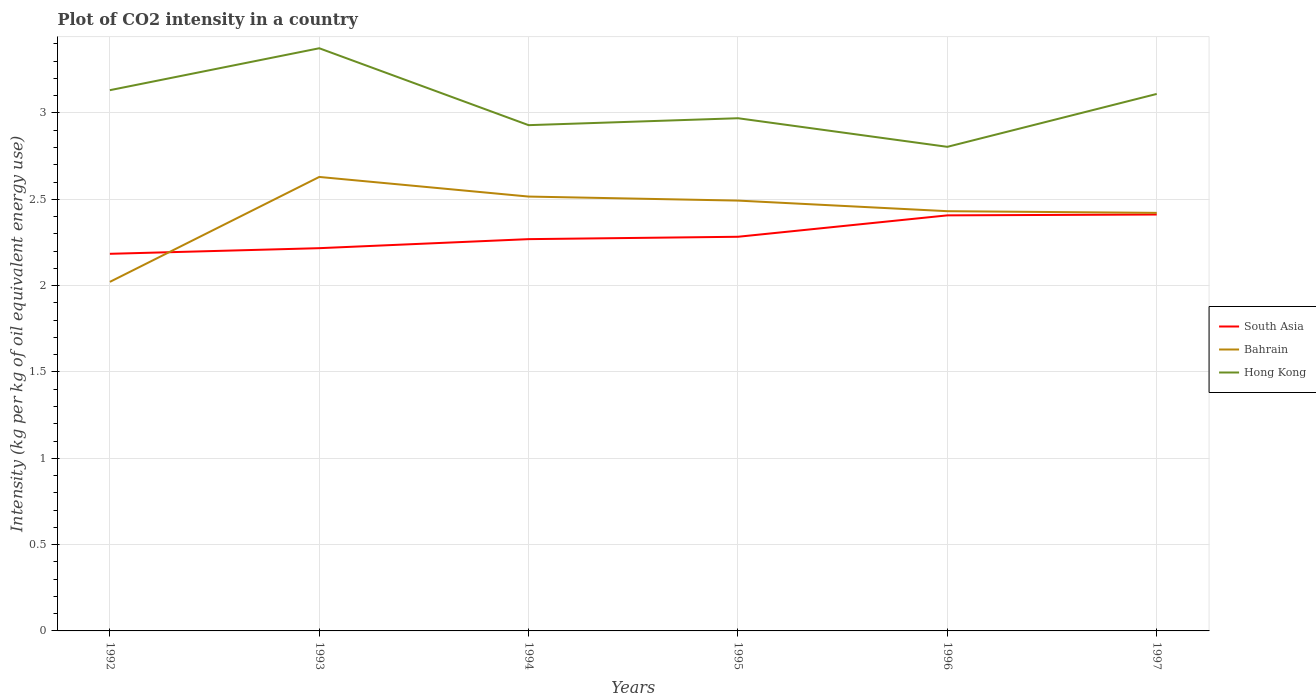Does the line corresponding to South Asia intersect with the line corresponding to Bahrain?
Your response must be concise. Yes. Across all years, what is the maximum CO2 intensity in in Hong Kong?
Your answer should be compact. 2.8. In which year was the CO2 intensity in in South Asia maximum?
Keep it short and to the point. 1992. What is the total CO2 intensity in in South Asia in the graph?
Your answer should be compact. -0.13. What is the difference between the highest and the second highest CO2 intensity in in Bahrain?
Your answer should be very brief. 0.61. What is the difference between two consecutive major ticks on the Y-axis?
Your answer should be very brief. 0.5. Are the values on the major ticks of Y-axis written in scientific E-notation?
Provide a short and direct response. No. Does the graph contain any zero values?
Give a very brief answer. No. Where does the legend appear in the graph?
Your answer should be very brief. Center right. How are the legend labels stacked?
Your response must be concise. Vertical. What is the title of the graph?
Offer a terse response. Plot of CO2 intensity in a country. What is the label or title of the Y-axis?
Provide a short and direct response. Intensity (kg per kg of oil equivalent energy use). What is the Intensity (kg per kg of oil equivalent energy use) of South Asia in 1992?
Offer a very short reply. 2.18. What is the Intensity (kg per kg of oil equivalent energy use) of Bahrain in 1992?
Provide a succinct answer. 2.02. What is the Intensity (kg per kg of oil equivalent energy use) in Hong Kong in 1992?
Keep it short and to the point. 3.13. What is the Intensity (kg per kg of oil equivalent energy use) in South Asia in 1993?
Ensure brevity in your answer.  2.22. What is the Intensity (kg per kg of oil equivalent energy use) in Bahrain in 1993?
Keep it short and to the point. 2.63. What is the Intensity (kg per kg of oil equivalent energy use) in Hong Kong in 1993?
Make the answer very short. 3.38. What is the Intensity (kg per kg of oil equivalent energy use) in South Asia in 1994?
Your answer should be compact. 2.27. What is the Intensity (kg per kg of oil equivalent energy use) in Bahrain in 1994?
Offer a terse response. 2.52. What is the Intensity (kg per kg of oil equivalent energy use) in Hong Kong in 1994?
Make the answer very short. 2.93. What is the Intensity (kg per kg of oil equivalent energy use) of South Asia in 1995?
Offer a very short reply. 2.28. What is the Intensity (kg per kg of oil equivalent energy use) of Bahrain in 1995?
Give a very brief answer. 2.49. What is the Intensity (kg per kg of oil equivalent energy use) of Hong Kong in 1995?
Offer a very short reply. 2.97. What is the Intensity (kg per kg of oil equivalent energy use) of South Asia in 1996?
Your answer should be compact. 2.41. What is the Intensity (kg per kg of oil equivalent energy use) in Bahrain in 1996?
Make the answer very short. 2.43. What is the Intensity (kg per kg of oil equivalent energy use) in Hong Kong in 1996?
Offer a terse response. 2.8. What is the Intensity (kg per kg of oil equivalent energy use) of South Asia in 1997?
Give a very brief answer. 2.41. What is the Intensity (kg per kg of oil equivalent energy use) in Bahrain in 1997?
Give a very brief answer. 2.42. What is the Intensity (kg per kg of oil equivalent energy use) in Hong Kong in 1997?
Provide a succinct answer. 3.11. Across all years, what is the maximum Intensity (kg per kg of oil equivalent energy use) in South Asia?
Provide a succinct answer. 2.41. Across all years, what is the maximum Intensity (kg per kg of oil equivalent energy use) in Bahrain?
Your answer should be compact. 2.63. Across all years, what is the maximum Intensity (kg per kg of oil equivalent energy use) of Hong Kong?
Offer a terse response. 3.38. Across all years, what is the minimum Intensity (kg per kg of oil equivalent energy use) in South Asia?
Offer a very short reply. 2.18. Across all years, what is the minimum Intensity (kg per kg of oil equivalent energy use) in Bahrain?
Ensure brevity in your answer.  2.02. Across all years, what is the minimum Intensity (kg per kg of oil equivalent energy use) in Hong Kong?
Ensure brevity in your answer.  2.8. What is the total Intensity (kg per kg of oil equivalent energy use) of South Asia in the graph?
Your answer should be very brief. 13.77. What is the total Intensity (kg per kg of oil equivalent energy use) in Bahrain in the graph?
Ensure brevity in your answer.  14.51. What is the total Intensity (kg per kg of oil equivalent energy use) in Hong Kong in the graph?
Give a very brief answer. 18.32. What is the difference between the Intensity (kg per kg of oil equivalent energy use) of South Asia in 1992 and that in 1993?
Offer a terse response. -0.03. What is the difference between the Intensity (kg per kg of oil equivalent energy use) of Bahrain in 1992 and that in 1993?
Make the answer very short. -0.61. What is the difference between the Intensity (kg per kg of oil equivalent energy use) in Hong Kong in 1992 and that in 1993?
Keep it short and to the point. -0.24. What is the difference between the Intensity (kg per kg of oil equivalent energy use) in South Asia in 1992 and that in 1994?
Provide a succinct answer. -0.08. What is the difference between the Intensity (kg per kg of oil equivalent energy use) of Bahrain in 1992 and that in 1994?
Ensure brevity in your answer.  -0.49. What is the difference between the Intensity (kg per kg of oil equivalent energy use) in Hong Kong in 1992 and that in 1994?
Your answer should be very brief. 0.2. What is the difference between the Intensity (kg per kg of oil equivalent energy use) in South Asia in 1992 and that in 1995?
Offer a very short reply. -0.1. What is the difference between the Intensity (kg per kg of oil equivalent energy use) of Bahrain in 1992 and that in 1995?
Your answer should be very brief. -0.47. What is the difference between the Intensity (kg per kg of oil equivalent energy use) of Hong Kong in 1992 and that in 1995?
Provide a short and direct response. 0.16. What is the difference between the Intensity (kg per kg of oil equivalent energy use) in South Asia in 1992 and that in 1996?
Ensure brevity in your answer.  -0.22. What is the difference between the Intensity (kg per kg of oil equivalent energy use) in Bahrain in 1992 and that in 1996?
Your answer should be very brief. -0.41. What is the difference between the Intensity (kg per kg of oil equivalent energy use) of Hong Kong in 1992 and that in 1996?
Offer a very short reply. 0.33. What is the difference between the Intensity (kg per kg of oil equivalent energy use) in South Asia in 1992 and that in 1997?
Offer a terse response. -0.23. What is the difference between the Intensity (kg per kg of oil equivalent energy use) of Bahrain in 1992 and that in 1997?
Your answer should be very brief. -0.4. What is the difference between the Intensity (kg per kg of oil equivalent energy use) in Hong Kong in 1992 and that in 1997?
Make the answer very short. 0.02. What is the difference between the Intensity (kg per kg of oil equivalent energy use) of South Asia in 1993 and that in 1994?
Offer a terse response. -0.05. What is the difference between the Intensity (kg per kg of oil equivalent energy use) of Bahrain in 1993 and that in 1994?
Make the answer very short. 0.11. What is the difference between the Intensity (kg per kg of oil equivalent energy use) in Hong Kong in 1993 and that in 1994?
Offer a terse response. 0.45. What is the difference between the Intensity (kg per kg of oil equivalent energy use) of South Asia in 1993 and that in 1995?
Provide a succinct answer. -0.07. What is the difference between the Intensity (kg per kg of oil equivalent energy use) of Bahrain in 1993 and that in 1995?
Your response must be concise. 0.14. What is the difference between the Intensity (kg per kg of oil equivalent energy use) in Hong Kong in 1993 and that in 1995?
Offer a very short reply. 0.41. What is the difference between the Intensity (kg per kg of oil equivalent energy use) in South Asia in 1993 and that in 1996?
Give a very brief answer. -0.19. What is the difference between the Intensity (kg per kg of oil equivalent energy use) in Bahrain in 1993 and that in 1996?
Provide a succinct answer. 0.2. What is the difference between the Intensity (kg per kg of oil equivalent energy use) in Hong Kong in 1993 and that in 1996?
Provide a short and direct response. 0.57. What is the difference between the Intensity (kg per kg of oil equivalent energy use) in South Asia in 1993 and that in 1997?
Your answer should be compact. -0.19. What is the difference between the Intensity (kg per kg of oil equivalent energy use) in Bahrain in 1993 and that in 1997?
Provide a succinct answer. 0.21. What is the difference between the Intensity (kg per kg of oil equivalent energy use) of Hong Kong in 1993 and that in 1997?
Your answer should be very brief. 0.26. What is the difference between the Intensity (kg per kg of oil equivalent energy use) in South Asia in 1994 and that in 1995?
Give a very brief answer. -0.01. What is the difference between the Intensity (kg per kg of oil equivalent energy use) in Bahrain in 1994 and that in 1995?
Give a very brief answer. 0.02. What is the difference between the Intensity (kg per kg of oil equivalent energy use) of Hong Kong in 1994 and that in 1995?
Provide a succinct answer. -0.04. What is the difference between the Intensity (kg per kg of oil equivalent energy use) in South Asia in 1994 and that in 1996?
Your answer should be compact. -0.14. What is the difference between the Intensity (kg per kg of oil equivalent energy use) in Bahrain in 1994 and that in 1996?
Your answer should be compact. 0.08. What is the difference between the Intensity (kg per kg of oil equivalent energy use) of Hong Kong in 1994 and that in 1996?
Your answer should be compact. 0.13. What is the difference between the Intensity (kg per kg of oil equivalent energy use) in South Asia in 1994 and that in 1997?
Offer a terse response. -0.14. What is the difference between the Intensity (kg per kg of oil equivalent energy use) of Bahrain in 1994 and that in 1997?
Your answer should be compact. 0.09. What is the difference between the Intensity (kg per kg of oil equivalent energy use) of Hong Kong in 1994 and that in 1997?
Your answer should be very brief. -0.18. What is the difference between the Intensity (kg per kg of oil equivalent energy use) in South Asia in 1995 and that in 1996?
Offer a terse response. -0.12. What is the difference between the Intensity (kg per kg of oil equivalent energy use) in Bahrain in 1995 and that in 1996?
Give a very brief answer. 0.06. What is the difference between the Intensity (kg per kg of oil equivalent energy use) in Hong Kong in 1995 and that in 1996?
Keep it short and to the point. 0.17. What is the difference between the Intensity (kg per kg of oil equivalent energy use) in South Asia in 1995 and that in 1997?
Ensure brevity in your answer.  -0.13. What is the difference between the Intensity (kg per kg of oil equivalent energy use) in Bahrain in 1995 and that in 1997?
Your response must be concise. 0.07. What is the difference between the Intensity (kg per kg of oil equivalent energy use) in Hong Kong in 1995 and that in 1997?
Your answer should be very brief. -0.14. What is the difference between the Intensity (kg per kg of oil equivalent energy use) of South Asia in 1996 and that in 1997?
Give a very brief answer. -0. What is the difference between the Intensity (kg per kg of oil equivalent energy use) in Bahrain in 1996 and that in 1997?
Make the answer very short. 0.01. What is the difference between the Intensity (kg per kg of oil equivalent energy use) in Hong Kong in 1996 and that in 1997?
Provide a succinct answer. -0.31. What is the difference between the Intensity (kg per kg of oil equivalent energy use) of South Asia in 1992 and the Intensity (kg per kg of oil equivalent energy use) of Bahrain in 1993?
Give a very brief answer. -0.45. What is the difference between the Intensity (kg per kg of oil equivalent energy use) in South Asia in 1992 and the Intensity (kg per kg of oil equivalent energy use) in Hong Kong in 1993?
Offer a very short reply. -1.19. What is the difference between the Intensity (kg per kg of oil equivalent energy use) of Bahrain in 1992 and the Intensity (kg per kg of oil equivalent energy use) of Hong Kong in 1993?
Keep it short and to the point. -1.35. What is the difference between the Intensity (kg per kg of oil equivalent energy use) in South Asia in 1992 and the Intensity (kg per kg of oil equivalent energy use) in Bahrain in 1994?
Provide a succinct answer. -0.33. What is the difference between the Intensity (kg per kg of oil equivalent energy use) of South Asia in 1992 and the Intensity (kg per kg of oil equivalent energy use) of Hong Kong in 1994?
Keep it short and to the point. -0.75. What is the difference between the Intensity (kg per kg of oil equivalent energy use) of Bahrain in 1992 and the Intensity (kg per kg of oil equivalent energy use) of Hong Kong in 1994?
Give a very brief answer. -0.91. What is the difference between the Intensity (kg per kg of oil equivalent energy use) in South Asia in 1992 and the Intensity (kg per kg of oil equivalent energy use) in Bahrain in 1995?
Your response must be concise. -0.31. What is the difference between the Intensity (kg per kg of oil equivalent energy use) in South Asia in 1992 and the Intensity (kg per kg of oil equivalent energy use) in Hong Kong in 1995?
Your answer should be very brief. -0.79. What is the difference between the Intensity (kg per kg of oil equivalent energy use) in Bahrain in 1992 and the Intensity (kg per kg of oil equivalent energy use) in Hong Kong in 1995?
Give a very brief answer. -0.95. What is the difference between the Intensity (kg per kg of oil equivalent energy use) in South Asia in 1992 and the Intensity (kg per kg of oil equivalent energy use) in Bahrain in 1996?
Provide a succinct answer. -0.25. What is the difference between the Intensity (kg per kg of oil equivalent energy use) of South Asia in 1992 and the Intensity (kg per kg of oil equivalent energy use) of Hong Kong in 1996?
Your answer should be very brief. -0.62. What is the difference between the Intensity (kg per kg of oil equivalent energy use) of Bahrain in 1992 and the Intensity (kg per kg of oil equivalent energy use) of Hong Kong in 1996?
Make the answer very short. -0.78. What is the difference between the Intensity (kg per kg of oil equivalent energy use) in South Asia in 1992 and the Intensity (kg per kg of oil equivalent energy use) in Bahrain in 1997?
Make the answer very short. -0.24. What is the difference between the Intensity (kg per kg of oil equivalent energy use) of South Asia in 1992 and the Intensity (kg per kg of oil equivalent energy use) of Hong Kong in 1997?
Your answer should be compact. -0.93. What is the difference between the Intensity (kg per kg of oil equivalent energy use) of Bahrain in 1992 and the Intensity (kg per kg of oil equivalent energy use) of Hong Kong in 1997?
Ensure brevity in your answer.  -1.09. What is the difference between the Intensity (kg per kg of oil equivalent energy use) in South Asia in 1993 and the Intensity (kg per kg of oil equivalent energy use) in Bahrain in 1994?
Provide a succinct answer. -0.3. What is the difference between the Intensity (kg per kg of oil equivalent energy use) in South Asia in 1993 and the Intensity (kg per kg of oil equivalent energy use) in Hong Kong in 1994?
Ensure brevity in your answer.  -0.71. What is the difference between the Intensity (kg per kg of oil equivalent energy use) of Bahrain in 1993 and the Intensity (kg per kg of oil equivalent energy use) of Hong Kong in 1994?
Your answer should be very brief. -0.3. What is the difference between the Intensity (kg per kg of oil equivalent energy use) of South Asia in 1993 and the Intensity (kg per kg of oil equivalent energy use) of Bahrain in 1995?
Provide a short and direct response. -0.28. What is the difference between the Intensity (kg per kg of oil equivalent energy use) in South Asia in 1993 and the Intensity (kg per kg of oil equivalent energy use) in Hong Kong in 1995?
Provide a short and direct response. -0.75. What is the difference between the Intensity (kg per kg of oil equivalent energy use) of Bahrain in 1993 and the Intensity (kg per kg of oil equivalent energy use) of Hong Kong in 1995?
Your answer should be very brief. -0.34. What is the difference between the Intensity (kg per kg of oil equivalent energy use) in South Asia in 1993 and the Intensity (kg per kg of oil equivalent energy use) in Bahrain in 1996?
Offer a very short reply. -0.21. What is the difference between the Intensity (kg per kg of oil equivalent energy use) of South Asia in 1993 and the Intensity (kg per kg of oil equivalent energy use) of Hong Kong in 1996?
Ensure brevity in your answer.  -0.59. What is the difference between the Intensity (kg per kg of oil equivalent energy use) in Bahrain in 1993 and the Intensity (kg per kg of oil equivalent energy use) in Hong Kong in 1996?
Offer a very short reply. -0.17. What is the difference between the Intensity (kg per kg of oil equivalent energy use) in South Asia in 1993 and the Intensity (kg per kg of oil equivalent energy use) in Bahrain in 1997?
Offer a very short reply. -0.2. What is the difference between the Intensity (kg per kg of oil equivalent energy use) in South Asia in 1993 and the Intensity (kg per kg of oil equivalent energy use) in Hong Kong in 1997?
Your response must be concise. -0.89. What is the difference between the Intensity (kg per kg of oil equivalent energy use) of Bahrain in 1993 and the Intensity (kg per kg of oil equivalent energy use) of Hong Kong in 1997?
Ensure brevity in your answer.  -0.48. What is the difference between the Intensity (kg per kg of oil equivalent energy use) in South Asia in 1994 and the Intensity (kg per kg of oil equivalent energy use) in Bahrain in 1995?
Make the answer very short. -0.22. What is the difference between the Intensity (kg per kg of oil equivalent energy use) of South Asia in 1994 and the Intensity (kg per kg of oil equivalent energy use) of Hong Kong in 1995?
Give a very brief answer. -0.7. What is the difference between the Intensity (kg per kg of oil equivalent energy use) in Bahrain in 1994 and the Intensity (kg per kg of oil equivalent energy use) in Hong Kong in 1995?
Provide a short and direct response. -0.45. What is the difference between the Intensity (kg per kg of oil equivalent energy use) of South Asia in 1994 and the Intensity (kg per kg of oil equivalent energy use) of Bahrain in 1996?
Keep it short and to the point. -0.16. What is the difference between the Intensity (kg per kg of oil equivalent energy use) of South Asia in 1994 and the Intensity (kg per kg of oil equivalent energy use) of Hong Kong in 1996?
Provide a succinct answer. -0.53. What is the difference between the Intensity (kg per kg of oil equivalent energy use) in Bahrain in 1994 and the Intensity (kg per kg of oil equivalent energy use) in Hong Kong in 1996?
Provide a short and direct response. -0.29. What is the difference between the Intensity (kg per kg of oil equivalent energy use) in South Asia in 1994 and the Intensity (kg per kg of oil equivalent energy use) in Bahrain in 1997?
Make the answer very short. -0.15. What is the difference between the Intensity (kg per kg of oil equivalent energy use) of South Asia in 1994 and the Intensity (kg per kg of oil equivalent energy use) of Hong Kong in 1997?
Your response must be concise. -0.84. What is the difference between the Intensity (kg per kg of oil equivalent energy use) of Bahrain in 1994 and the Intensity (kg per kg of oil equivalent energy use) of Hong Kong in 1997?
Your answer should be compact. -0.59. What is the difference between the Intensity (kg per kg of oil equivalent energy use) of South Asia in 1995 and the Intensity (kg per kg of oil equivalent energy use) of Bahrain in 1996?
Your response must be concise. -0.15. What is the difference between the Intensity (kg per kg of oil equivalent energy use) of South Asia in 1995 and the Intensity (kg per kg of oil equivalent energy use) of Hong Kong in 1996?
Ensure brevity in your answer.  -0.52. What is the difference between the Intensity (kg per kg of oil equivalent energy use) in Bahrain in 1995 and the Intensity (kg per kg of oil equivalent energy use) in Hong Kong in 1996?
Your answer should be very brief. -0.31. What is the difference between the Intensity (kg per kg of oil equivalent energy use) of South Asia in 1995 and the Intensity (kg per kg of oil equivalent energy use) of Bahrain in 1997?
Make the answer very short. -0.14. What is the difference between the Intensity (kg per kg of oil equivalent energy use) of South Asia in 1995 and the Intensity (kg per kg of oil equivalent energy use) of Hong Kong in 1997?
Offer a terse response. -0.83. What is the difference between the Intensity (kg per kg of oil equivalent energy use) in Bahrain in 1995 and the Intensity (kg per kg of oil equivalent energy use) in Hong Kong in 1997?
Provide a succinct answer. -0.62. What is the difference between the Intensity (kg per kg of oil equivalent energy use) of South Asia in 1996 and the Intensity (kg per kg of oil equivalent energy use) of Bahrain in 1997?
Keep it short and to the point. -0.01. What is the difference between the Intensity (kg per kg of oil equivalent energy use) in South Asia in 1996 and the Intensity (kg per kg of oil equivalent energy use) in Hong Kong in 1997?
Offer a very short reply. -0.7. What is the difference between the Intensity (kg per kg of oil equivalent energy use) in Bahrain in 1996 and the Intensity (kg per kg of oil equivalent energy use) in Hong Kong in 1997?
Your answer should be very brief. -0.68. What is the average Intensity (kg per kg of oil equivalent energy use) of South Asia per year?
Your answer should be very brief. 2.3. What is the average Intensity (kg per kg of oil equivalent energy use) in Bahrain per year?
Keep it short and to the point. 2.42. What is the average Intensity (kg per kg of oil equivalent energy use) of Hong Kong per year?
Give a very brief answer. 3.05. In the year 1992, what is the difference between the Intensity (kg per kg of oil equivalent energy use) of South Asia and Intensity (kg per kg of oil equivalent energy use) of Bahrain?
Make the answer very short. 0.16. In the year 1992, what is the difference between the Intensity (kg per kg of oil equivalent energy use) of South Asia and Intensity (kg per kg of oil equivalent energy use) of Hong Kong?
Your answer should be very brief. -0.95. In the year 1992, what is the difference between the Intensity (kg per kg of oil equivalent energy use) of Bahrain and Intensity (kg per kg of oil equivalent energy use) of Hong Kong?
Provide a short and direct response. -1.11. In the year 1993, what is the difference between the Intensity (kg per kg of oil equivalent energy use) in South Asia and Intensity (kg per kg of oil equivalent energy use) in Bahrain?
Your response must be concise. -0.41. In the year 1993, what is the difference between the Intensity (kg per kg of oil equivalent energy use) of South Asia and Intensity (kg per kg of oil equivalent energy use) of Hong Kong?
Provide a succinct answer. -1.16. In the year 1993, what is the difference between the Intensity (kg per kg of oil equivalent energy use) in Bahrain and Intensity (kg per kg of oil equivalent energy use) in Hong Kong?
Offer a very short reply. -0.75. In the year 1994, what is the difference between the Intensity (kg per kg of oil equivalent energy use) in South Asia and Intensity (kg per kg of oil equivalent energy use) in Bahrain?
Your answer should be very brief. -0.25. In the year 1994, what is the difference between the Intensity (kg per kg of oil equivalent energy use) of South Asia and Intensity (kg per kg of oil equivalent energy use) of Hong Kong?
Offer a very short reply. -0.66. In the year 1994, what is the difference between the Intensity (kg per kg of oil equivalent energy use) in Bahrain and Intensity (kg per kg of oil equivalent energy use) in Hong Kong?
Keep it short and to the point. -0.41. In the year 1995, what is the difference between the Intensity (kg per kg of oil equivalent energy use) in South Asia and Intensity (kg per kg of oil equivalent energy use) in Bahrain?
Your response must be concise. -0.21. In the year 1995, what is the difference between the Intensity (kg per kg of oil equivalent energy use) in South Asia and Intensity (kg per kg of oil equivalent energy use) in Hong Kong?
Offer a very short reply. -0.69. In the year 1995, what is the difference between the Intensity (kg per kg of oil equivalent energy use) in Bahrain and Intensity (kg per kg of oil equivalent energy use) in Hong Kong?
Ensure brevity in your answer.  -0.48. In the year 1996, what is the difference between the Intensity (kg per kg of oil equivalent energy use) of South Asia and Intensity (kg per kg of oil equivalent energy use) of Bahrain?
Offer a terse response. -0.02. In the year 1996, what is the difference between the Intensity (kg per kg of oil equivalent energy use) in South Asia and Intensity (kg per kg of oil equivalent energy use) in Hong Kong?
Offer a terse response. -0.4. In the year 1996, what is the difference between the Intensity (kg per kg of oil equivalent energy use) in Bahrain and Intensity (kg per kg of oil equivalent energy use) in Hong Kong?
Make the answer very short. -0.37. In the year 1997, what is the difference between the Intensity (kg per kg of oil equivalent energy use) in South Asia and Intensity (kg per kg of oil equivalent energy use) in Bahrain?
Offer a terse response. -0.01. In the year 1997, what is the difference between the Intensity (kg per kg of oil equivalent energy use) in South Asia and Intensity (kg per kg of oil equivalent energy use) in Hong Kong?
Ensure brevity in your answer.  -0.7. In the year 1997, what is the difference between the Intensity (kg per kg of oil equivalent energy use) of Bahrain and Intensity (kg per kg of oil equivalent energy use) of Hong Kong?
Make the answer very short. -0.69. What is the ratio of the Intensity (kg per kg of oil equivalent energy use) in Bahrain in 1992 to that in 1993?
Give a very brief answer. 0.77. What is the ratio of the Intensity (kg per kg of oil equivalent energy use) of Hong Kong in 1992 to that in 1993?
Your answer should be compact. 0.93. What is the ratio of the Intensity (kg per kg of oil equivalent energy use) in South Asia in 1992 to that in 1994?
Keep it short and to the point. 0.96. What is the ratio of the Intensity (kg per kg of oil equivalent energy use) in Bahrain in 1992 to that in 1994?
Ensure brevity in your answer.  0.8. What is the ratio of the Intensity (kg per kg of oil equivalent energy use) of Hong Kong in 1992 to that in 1994?
Offer a very short reply. 1.07. What is the ratio of the Intensity (kg per kg of oil equivalent energy use) of South Asia in 1992 to that in 1995?
Your answer should be very brief. 0.96. What is the ratio of the Intensity (kg per kg of oil equivalent energy use) of Bahrain in 1992 to that in 1995?
Offer a terse response. 0.81. What is the ratio of the Intensity (kg per kg of oil equivalent energy use) in Hong Kong in 1992 to that in 1995?
Keep it short and to the point. 1.05. What is the ratio of the Intensity (kg per kg of oil equivalent energy use) in South Asia in 1992 to that in 1996?
Offer a very short reply. 0.91. What is the ratio of the Intensity (kg per kg of oil equivalent energy use) in Bahrain in 1992 to that in 1996?
Your answer should be compact. 0.83. What is the ratio of the Intensity (kg per kg of oil equivalent energy use) of Hong Kong in 1992 to that in 1996?
Give a very brief answer. 1.12. What is the ratio of the Intensity (kg per kg of oil equivalent energy use) of South Asia in 1992 to that in 1997?
Give a very brief answer. 0.91. What is the ratio of the Intensity (kg per kg of oil equivalent energy use) of Bahrain in 1992 to that in 1997?
Give a very brief answer. 0.83. What is the ratio of the Intensity (kg per kg of oil equivalent energy use) in Hong Kong in 1992 to that in 1997?
Offer a terse response. 1.01. What is the ratio of the Intensity (kg per kg of oil equivalent energy use) of Bahrain in 1993 to that in 1994?
Provide a short and direct response. 1.05. What is the ratio of the Intensity (kg per kg of oil equivalent energy use) in Hong Kong in 1993 to that in 1994?
Make the answer very short. 1.15. What is the ratio of the Intensity (kg per kg of oil equivalent energy use) of South Asia in 1993 to that in 1995?
Give a very brief answer. 0.97. What is the ratio of the Intensity (kg per kg of oil equivalent energy use) in Bahrain in 1993 to that in 1995?
Provide a succinct answer. 1.05. What is the ratio of the Intensity (kg per kg of oil equivalent energy use) of Hong Kong in 1993 to that in 1995?
Offer a terse response. 1.14. What is the ratio of the Intensity (kg per kg of oil equivalent energy use) of South Asia in 1993 to that in 1996?
Offer a terse response. 0.92. What is the ratio of the Intensity (kg per kg of oil equivalent energy use) of Bahrain in 1993 to that in 1996?
Provide a short and direct response. 1.08. What is the ratio of the Intensity (kg per kg of oil equivalent energy use) of Hong Kong in 1993 to that in 1996?
Provide a succinct answer. 1.2. What is the ratio of the Intensity (kg per kg of oil equivalent energy use) in South Asia in 1993 to that in 1997?
Make the answer very short. 0.92. What is the ratio of the Intensity (kg per kg of oil equivalent energy use) in Bahrain in 1993 to that in 1997?
Provide a short and direct response. 1.09. What is the ratio of the Intensity (kg per kg of oil equivalent energy use) in Hong Kong in 1993 to that in 1997?
Give a very brief answer. 1.09. What is the ratio of the Intensity (kg per kg of oil equivalent energy use) in Bahrain in 1994 to that in 1995?
Your response must be concise. 1.01. What is the ratio of the Intensity (kg per kg of oil equivalent energy use) in Hong Kong in 1994 to that in 1995?
Give a very brief answer. 0.99. What is the ratio of the Intensity (kg per kg of oil equivalent energy use) in South Asia in 1994 to that in 1996?
Make the answer very short. 0.94. What is the ratio of the Intensity (kg per kg of oil equivalent energy use) of Bahrain in 1994 to that in 1996?
Keep it short and to the point. 1.03. What is the ratio of the Intensity (kg per kg of oil equivalent energy use) of Hong Kong in 1994 to that in 1996?
Provide a succinct answer. 1.04. What is the ratio of the Intensity (kg per kg of oil equivalent energy use) in South Asia in 1994 to that in 1997?
Give a very brief answer. 0.94. What is the ratio of the Intensity (kg per kg of oil equivalent energy use) of Bahrain in 1994 to that in 1997?
Keep it short and to the point. 1.04. What is the ratio of the Intensity (kg per kg of oil equivalent energy use) of Hong Kong in 1994 to that in 1997?
Offer a terse response. 0.94. What is the ratio of the Intensity (kg per kg of oil equivalent energy use) in South Asia in 1995 to that in 1996?
Your answer should be very brief. 0.95. What is the ratio of the Intensity (kg per kg of oil equivalent energy use) in Bahrain in 1995 to that in 1996?
Offer a very short reply. 1.03. What is the ratio of the Intensity (kg per kg of oil equivalent energy use) in Hong Kong in 1995 to that in 1996?
Your answer should be compact. 1.06. What is the ratio of the Intensity (kg per kg of oil equivalent energy use) in South Asia in 1995 to that in 1997?
Make the answer very short. 0.95. What is the ratio of the Intensity (kg per kg of oil equivalent energy use) of Bahrain in 1995 to that in 1997?
Keep it short and to the point. 1.03. What is the ratio of the Intensity (kg per kg of oil equivalent energy use) of Hong Kong in 1995 to that in 1997?
Provide a short and direct response. 0.95. What is the ratio of the Intensity (kg per kg of oil equivalent energy use) in Bahrain in 1996 to that in 1997?
Give a very brief answer. 1. What is the ratio of the Intensity (kg per kg of oil equivalent energy use) in Hong Kong in 1996 to that in 1997?
Provide a succinct answer. 0.9. What is the difference between the highest and the second highest Intensity (kg per kg of oil equivalent energy use) in South Asia?
Ensure brevity in your answer.  0. What is the difference between the highest and the second highest Intensity (kg per kg of oil equivalent energy use) of Bahrain?
Give a very brief answer. 0.11. What is the difference between the highest and the second highest Intensity (kg per kg of oil equivalent energy use) of Hong Kong?
Offer a terse response. 0.24. What is the difference between the highest and the lowest Intensity (kg per kg of oil equivalent energy use) in South Asia?
Keep it short and to the point. 0.23. What is the difference between the highest and the lowest Intensity (kg per kg of oil equivalent energy use) of Bahrain?
Your answer should be very brief. 0.61. What is the difference between the highest and the lowest Intensity (kg per kg of oil equivalent energy use) in Hong Kong?
Offer a very short reply. 0.57. 